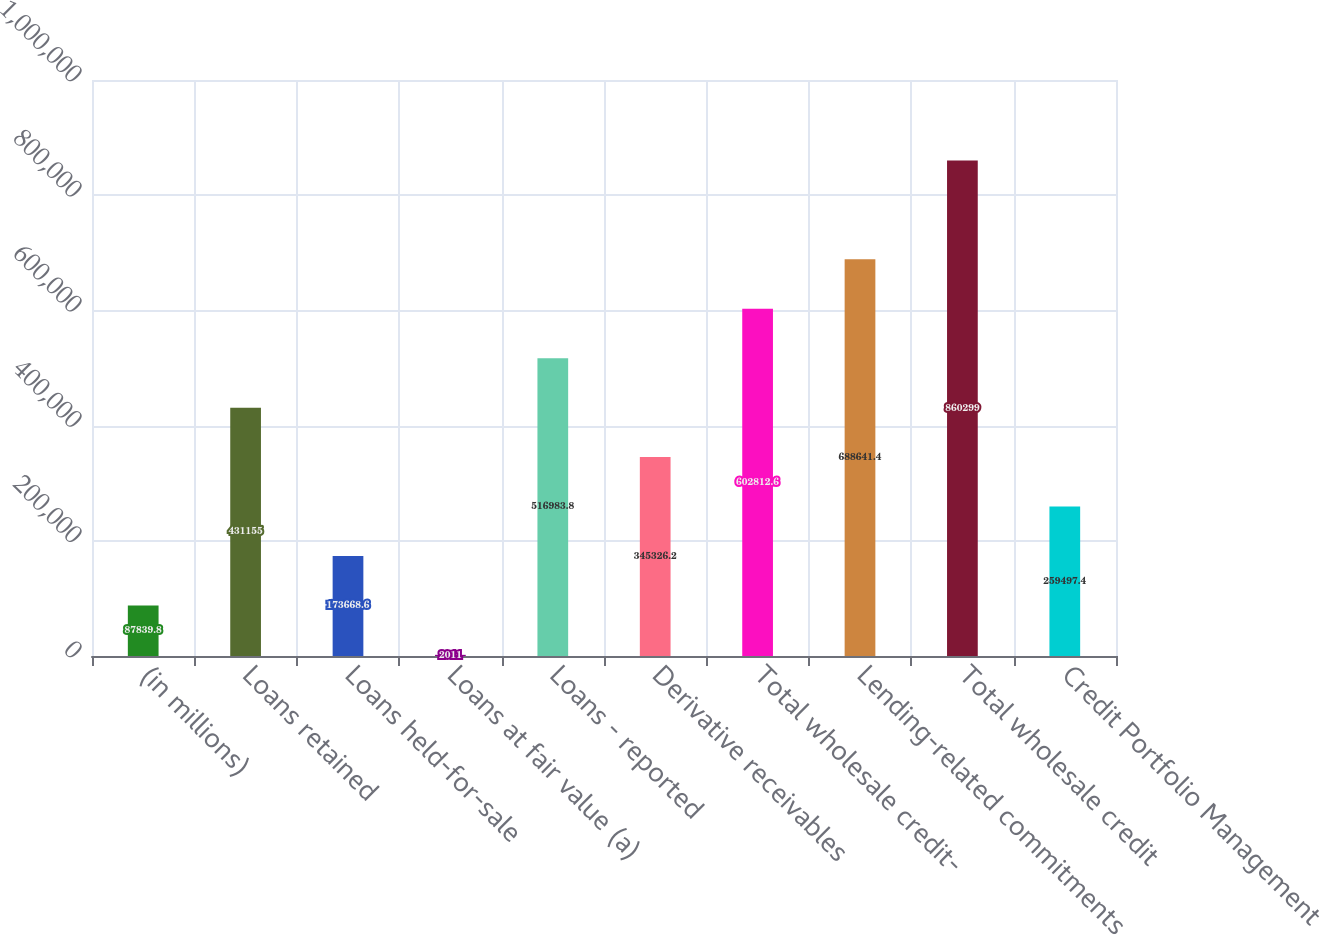<chart> <loc_0><loc_0><loc_500><loc_500><bar_chart><fcel>(in millions)<fcel>Loans retained<fcel>Loans held-for-sale<fcel>Loans at fair value (a)<fcel>Loans - reported<fcel>Derivative receivables<fcel>Total wholesale credit-<fcel>Lending-related commitments<fcel>Total wholesale credit<fcel>Credit Portfolio Management<nl><fcel>87839.8<fcel>431155<fcel>173669<fcel>2011<fcel>516984<fcel>345326<fcel>602813<fcel>688641<fcel>860299<fcel>259497<nl></chart> 